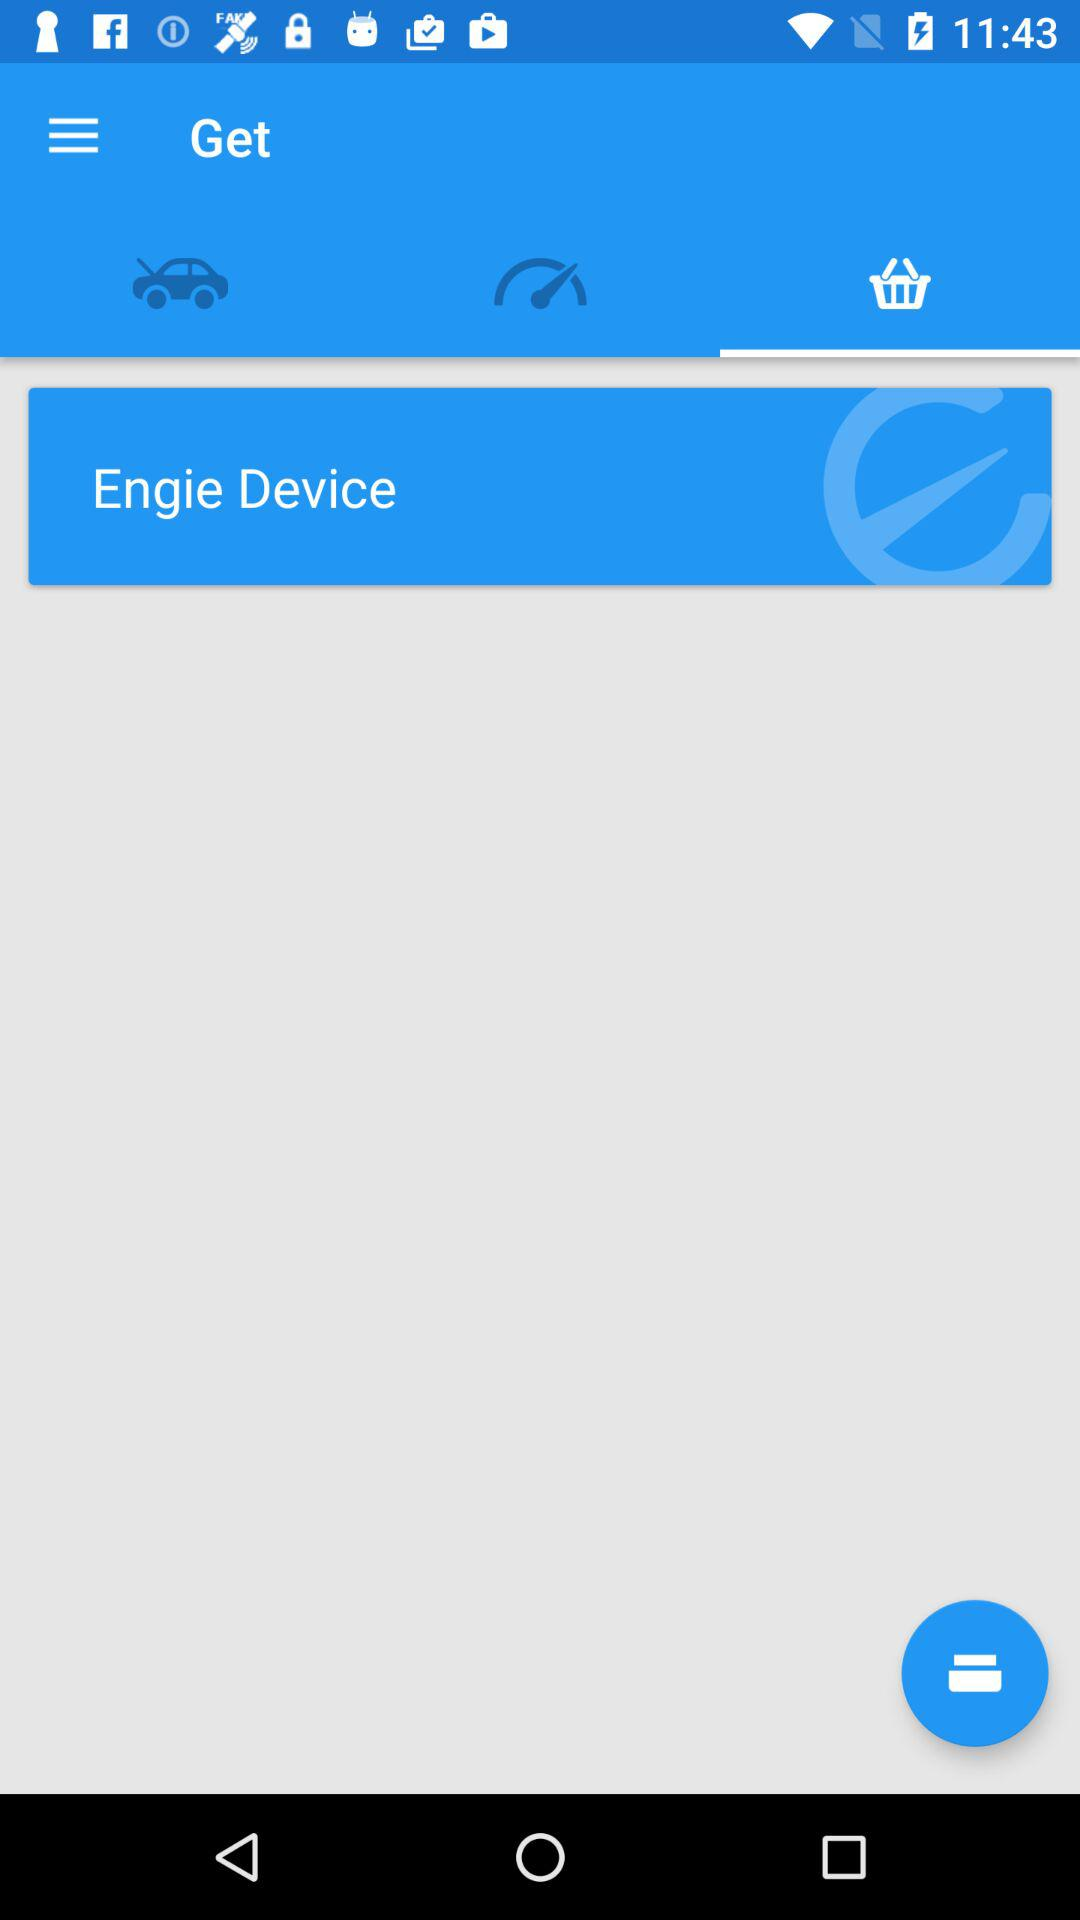Which option has been selected? The selected option is "Basket". 